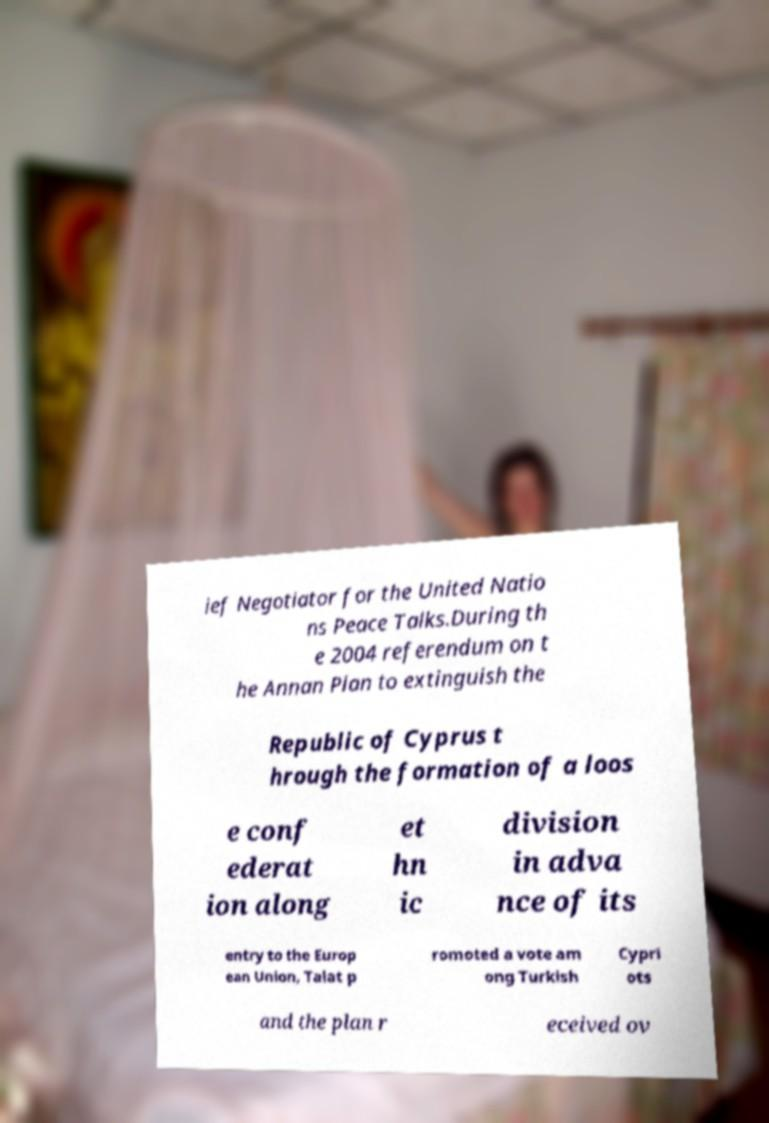What messages or text are displayed in this image? I need them in a readable, typed format. ief Negotiator for the United Natio ns Peace Talks.During th e 2004 referendum on t he Annan Plan to extinguish the Republic of Cyprus t hrough the formation of a loos e conf ederat ion along et hn ic division in adva nce of its entry to the Europ ean Union, Talat p romoted a vote am ong Turkish Cypri ots and the plan r eceived ov 